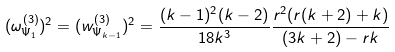Convert formula to latex. <formula><loc_0><loc_0><loc_500><loc_500>( \omega ^ { ( 3 ) } _ { \Psi _ { 1 } } ) ^ { 2 } = ( w ^ { ( 3 ) } _ { \Psi _ { k - 1 } } ) ^ { 2 } = \frac { ( k - 1 ) ^ { 2 } ( k - 2 ) } { 1 8 k ^ { 3 } } \frac { r ^ { 2 } ( r ( k + 2 ) + k ) } { ( 3 k + 2 ) - r k }</formula> 